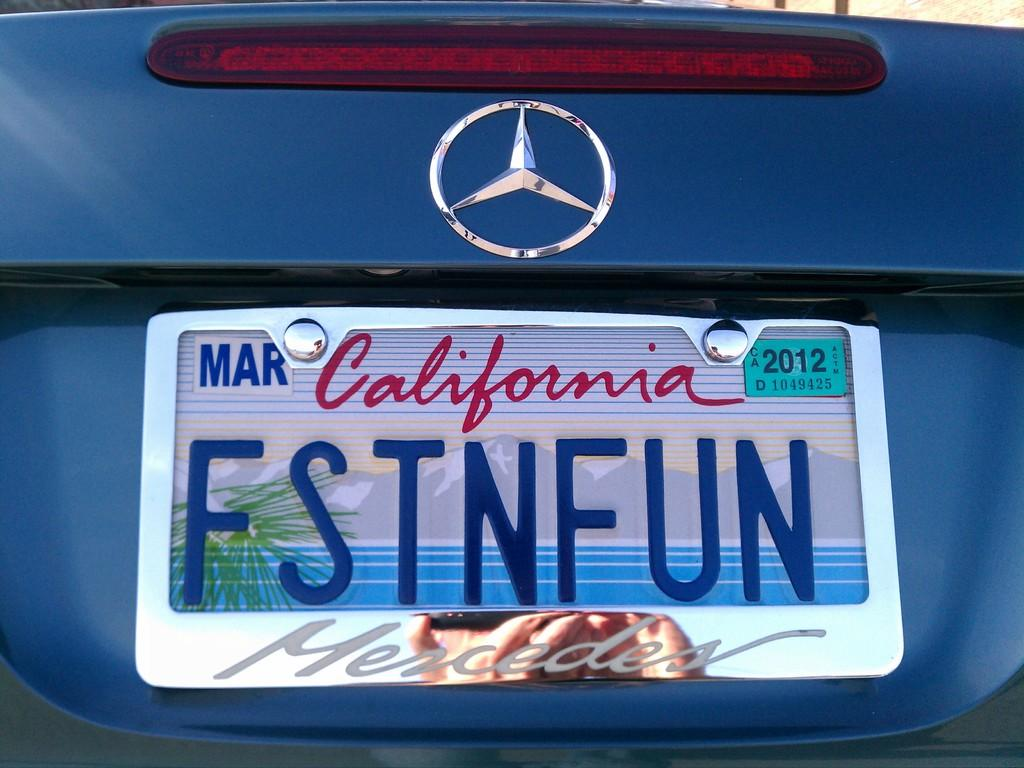<image>
Offer a succinct explanation of the picture presented. A California license plate on a Mercedes says FSTNFUN. 